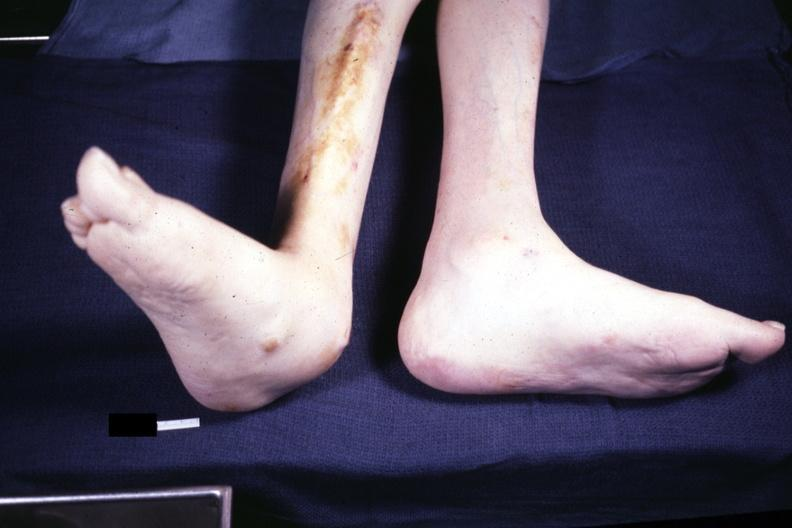does this image show typical deformity with lateral deviation case 31?
Answer the question using a single word or phrase. Yes 